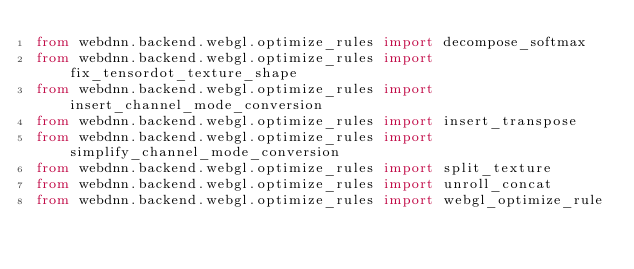<code> <loc_0><loc_0><loc_500><loc_500><_Python_>from webdnn.backend.webgl.optimize_rules import decompose_softmax
from webdnn.backend.webgl.optimize_rules import fix_tensordot_texture_shape
from webdnn.backend.webgl.optimize_rules import insert_channel_mode_conversion
from webdnn.backend.webgl.optimize_rules import insert_transpose
from webdnn.backend.webgl.optimize_rules import simplify_channel_mode_conversion
from webdnn.backend.webgl.optimize_rules import split_texture
from webdnn.backend.webgl.optimize_rules import unroll_concat
from webdnn.backend.webgl.optimize_rules import webgl_optimize_rule
</code> 